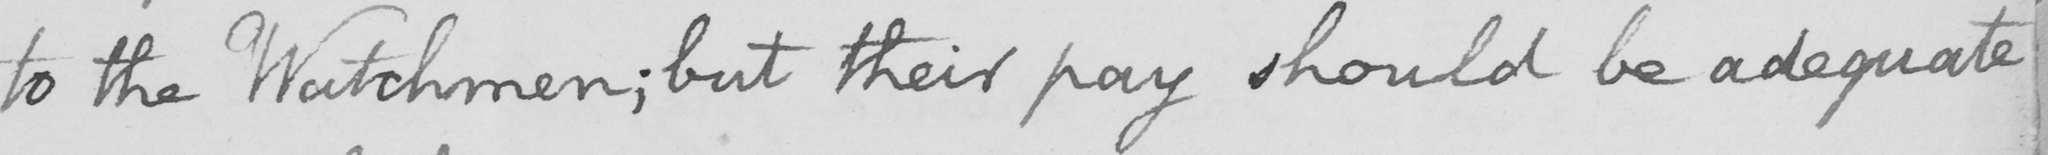What is written in this line of handwriting? to the Watchmen ; but their pay should be adequate 